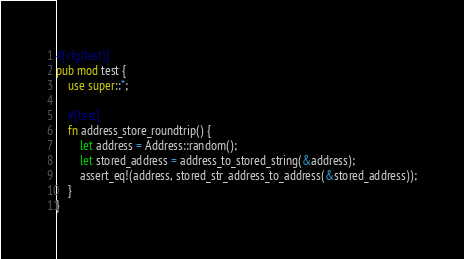<code> <loc_0><loc_0><loc_500><loc_500><_Rust_>
#[cfg(test)]
pub mod test {
    use super::*;

    #[test]
    fn address_store_roundtrip() {
        let address = Address::random();
        let stored_address = address_to_stored_string(&address);
        assert_eq!(address, stored_str_address_to_address(&stored_address));
    }
}
</code> 